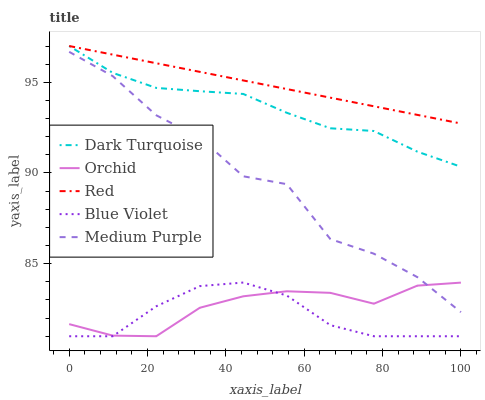Does Blue Violet have the minimum area under the curve?
Answer yes or no. Yes. Does Red have the maximum area under the curve?
Answer yes or no. Yes. Does Dark Turquoise have the minimum area under the curve?
Answer yes or no. No. Does Dark Turquoise have the maximum area under the curve?
Answer yes or no. No. Is Red the smoothest?
Answer yes or no. Yes. Is Medium Purple the roughest?
Answer yes or no. Yes. Is Dark Turquoise the smoothest?
Answer yes or no. No. Is Dark Turquoise the roughest?
Answer yes or no. No. Does Blue Violet have the lowest value?
Answer yes or no. Yes. Does Dark Turquoise have the lowest value?
Answer yes or no. No. Does Red have the highest value?
Answer yes or no. Yes. Does Blue Violet have the highest value?
Answer yes or no. No. Is Blue Violet less than Red?
Answer yes or no. Yes. Is Dark Turquoise greater than Blue Violet?
Answer yes or no. Yes. Does Medium Purple intersect Orchid?
Answer yes or no. Yes. Is Medium Purple less than Orchid?
Answer yes or no. No. Is Medium Purple greater than Orchid?
Answer yes or no. No. Does Blue Violet intersect Red?
Answer yes or no. No. 